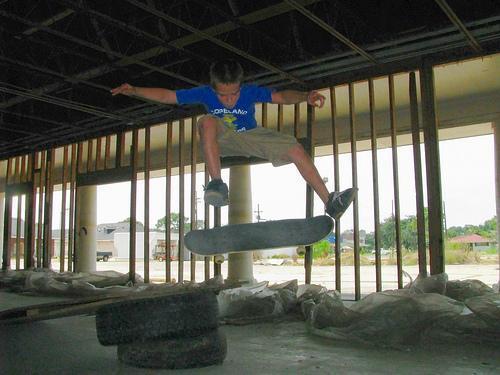How many kids?
Give a very brief answer. 1. 